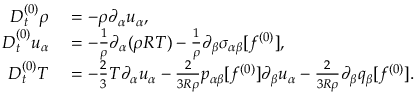<formula> <loc_0><loc_0><loc_500><loc_500>\begin{array} { r l } { D _ { t } ^ { ( 0 ) } \rho } & = - \rho \partial _ { \alpha } u _ { \alpha } , } \\ { D _ { t } ^ { ( 0 ) } u _ { \alpha } } & = - \frac { 1 } { \rho } \partial _ { \alpha } ( \rho R T ) - \frac { 1 } { \rho } \partial _ { \beta } \sigma _ { \alpha \beta } [ f ^ { ( 0 ) } ] , } \\ { D _ { t } ^ { ( 0 ) } T } & = - \frac { 2 } { 3 } T \partial _ { \alpha } u _ { \alpha } - \frac { 2 } { 3 R \rho } p _ { \alpha \beta } [ f ^ { ( 0 ) } ] \partial _ { \beta } u _ { \alpha } - \frac { 2 } { 3 R \rho } \partial _ { \beta } q _ { \beta } [ f ^ { ( 0 ) } ] . } \end{array}</formula> 